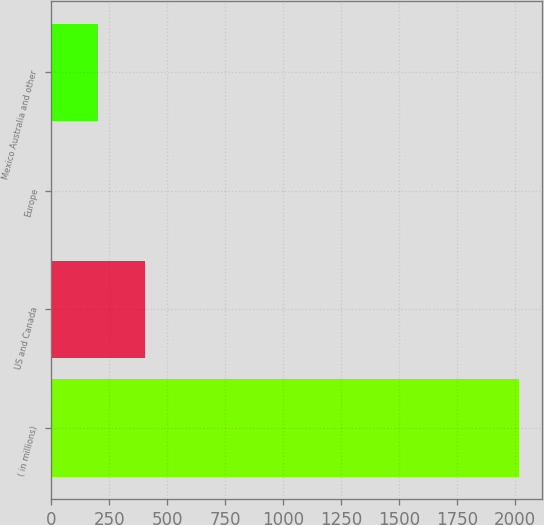<chart> <loc_0><loc_0><loc_500><loc_500><bar_chart><fcel>( in millions)<fcel>US and Canada<fcel>Europe<fcel>Mexico Australia and other<nl><fcel>2016<fcel>403.52<fcel>0.4<fcel>201.96<nl></chart> 